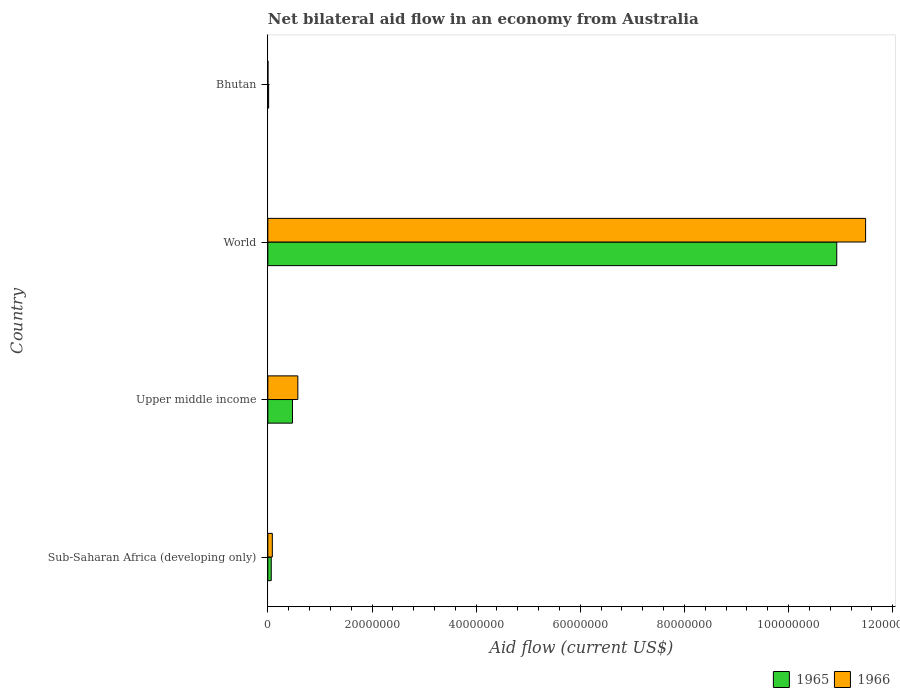How many different coloured bars are there?
Your response must be concise. 2. Are the number of bars on each tick of the Y-axis equal?
Your response must be concise. Yes. How many bars are there on the 2nd tick from the top?
Your answer should be very brief. 2. What is the label of the 1st group of bars from the top?
Your answer should be compact. Bhutan. In how many cases, is the number of bars for a given country not equal to the number of legend labels?
Your answer should be very brief. 0. What is the net bilateral aid flow in 1965 in Upper middle income?
Give a very brief answer. 4.73e+06. Across all countries, what is the maximum net bilateral aid flow in 1965?
Your answer should be compact. 1.09e+08. Across all countries, what is the minimum net bilateral aid flow in 1965?
Offer a terse response. 1.50e+05. In which country was the net bilateral aid flow in 1966 minimum?
Offer a terse response. Bhutan. What is the total net bilateral aid flow in 1965 in the graph?
Your response must be concise. 1.15e+08. What is the difference between the net bilateral aid flow in 1966 in Bhutan and that in Sub-Saharan Africa (developing only)?
Offer a very short reply. -8.40e+05. What is the difference between the net bilateral aid flow in 1965 in Sub-Saharan Africa (developing only) and the net bilateral aid flow in 1966 in World?
Make the answer very short. -1.14e+08. What is the average net bilateral aid flow in 1965 per country?
Provide a succinct answer. 2.87e+07. What is the ratio of the net bilateral aid flow in 1966 in Upper middle income to that in World?
Provide a short and direct response. 0.05. What is the difference between the highest and the second highest net bilateral aid flow in 1965?
Give a very brief answer. 1.05e+08. What is the difference between the highest and the lowest net bilateral aid flow in 1965?
Your response must be concise. 1.09e+08. Is the sum of the net bilateral aid flow in 1965 in Sub-Saharan Africa (developing only) and World greater than the maximum net bilateral aid flow in 1966 across all countries?
Offer a very short reply. No. What does the 1st bar from the top in World represents?
Your answer should be very brief. 1966. What does the 2nd bar from the bottom in World represents?
Provide a short and direct response. 1966. How many bars are there?
Keep it short and to the point. 8. How many countries are there in the graph?
Give a very brief answer. 4. Are the values on the major ticks of X-axis written in scientific E-notation?
Ensure brevity in your answer.  No. Does the graph contain grids?
Your answer should be very brief. No. Where does the legend appear in the graph?
Make the answer very short. Bottom right. How many legend labels are there?
Keep it short and to the point. 2. What is the title of the graph?
Make the answer very short. Net bilateral aid flow in an economy from Australia. Does "1966" appear as one of the legend labels in the graph?
Offer a very short reply. Yes. What is the label or title of the Y-axis?
Provide a short and direct response. Country. What is the Aid flow (current US$) of 1965 in Sub-Saharan Africa (developing only)?
Give a very brief answer. 6.50e+05. What is the Aid flow (current US$) in 1966 in Sub-Saharan Africa (developing only)?
Offer a very short reply. 8.60e+05. What is the Aid flow (current US$) in 1965 in Upper middle income?
Your answer should be very brief. 4.73e+06. What is the Aid flow (current US$) of 1966 in Upper middle income?
Ensure brevity in your answer.  5.76e+06. What is the Aid flow (current US$) in 1965 in World?
Your answer should be compact. 1.09e+08. What is the Aid flow (current US$) in 1966 in World?
Ensure brevity in your answer.  1.15e+08. What is the Aid flow (current US$) in 1966 in Bhutan?
Your answer should be very brief. 2.00e+04. Across all countries, what is the maximum Aid flow (current US$) in 1965?
Make the answer very short. 1.09e+08. Across all countries, what is the maximum Aid flow (current US$) in 1966?
Make the answer very short. 1.15e+08. Across all countries, what is the minimum Aid flow (current US$) in 1966?
Ensure brevity in your answer.  2.00e+04. What is the total Aid flow (current US$) in 1965 in the graph?
Ensure brevity in your answer.  1.15e+08. What is the total Aid flow (current US$) of 1966 in the graph?
Provide a succinct answer. 1.21e+08. What is the difference between the Aid flow (current US$) of 1965 in Sub-Saharan Africa (developing only) and that in Upper middle income?
Make the answer very short. -4.08e+06. What is the difference between the Aid flow (current US$) in 1966 in Sub-Saharan Africa (developing only) and that in Upper middle income?
Give a very brief answer. -4.90e+06. What is the difference between the Aid flow (current US$) of 1965 in Sub-Saharan Africa (developing only) and that in World?
Provide a succinct answer. -1.09e+08. What is the difference between the Aid flow (current US$) in 1966 in Sub-Saharan Africa (developing only) and that in World?
Keep it short and to the point. -1.14e+08. What is the difference between the Aid flow (current US$) of 1966 in Sub-Saharan Africa (developing only) and that in Bhutan?
Make the answer very short. 8.40e+05. What is the difference between the Aid flow (current US$) of 1965 in Upper middle income and that in World?
Keep it short and to the point. -1.05e+08. What is the difference between the Aid flow (current US$) of 1966 in Upper middle income and that in World?
Your answer should be compact. -1.09e+08. What is the difference between the Aid flow (current US$) of 1965 in Upper middle income and that in Bhutan?
Keep it short and to the point. 4.58e+06. What is the difference between the Aid flow (current US$) in 1966 in Upper middle income and that in Bhutan?
Your response must be concise. 5.74e+06. What is the difference between the Aid flow (current US$) of 1965 in World and that in Bhutan?
Make the answer very short. 1.09e+08. What is the difference between the Aid flow (current US$) in 1966 in World and that in Bhutan?
Ensure brevity in your answer.  1.15e+08. What is the difference between the Aid flow (current US$) in 1965 in Sub-Saharan Africa (developing only) and the Aid flow (current US$) in 1966 in Upper middle income?
Ensure brevity in your answer.  -5.11e+06. What is the difference between the Aid flow (current US$) of 1965 in Sub-Saharan Africa (developing only) and the Aid flow (current US$) of 1966 in World?
Ensure brevity in your answer.  -1.14e+08. What is the difference between the Aid flow (current US$) in 1965 in Sub-Saharan Africa (developing only) and the Aid flow (current US$) in 1966 in Bhutan?
Ensure brevity in your answer.  6.30e+05. What is the difference between the Aid flow (current US$) of 1965 in Upper middle income and the Aid flow (current US$) of 1966 in World?
Provide a succinct answer. -1.10e+08. What is the difference between the Aid flow (current US$) of 1965 in Upper middle income and the Aid flow (current US$) of 1966 in Bhutan?
Your response must be concise. 4.71e+06. What is the difference between the Aid flow (current US$) in 1965 in World and the Aid flow (current US$) in 1966 in Bhutan?
Make the answer very short. 1.09e+08. What is the average Aid flow (current US$) of 1965 per country?
Keep it short and to the point. 2.87e+07. What is the average Aid flow (current US$) in 1966 per country?
Make the answer very short. 3.04e+07. What is the difference between the Aid flow (current US$) in 1965 and Aid flow (current US$) in 1966 in Sub-Saharan Africa (developing only)?
Your response must be concise. -2.10e+05. What is the difference between the Aid flow (current US$) of 1965 and Aid flow (current US$) of 1966 in Upper middle income?
Give a very brief answer. -1.03e+06. What is the difference between the Aid flow (current US$) in 1965 and Aid flow (current US$) in 1966 in World?
Offer a terse response. -5.54e+06. What is the difference between the Aid flow (current US$) of 1965 and Aid flow (current US$) of 1966 in Bhutan?
Your answer should be very brief. 1.30e+05. What is the ratio of the Aid flow (current US$) in 1965 in Sub-Saharan Africa (developing only) to that in Upper middle income?
Offer a very short reply. 0.14. What is the ratio of the Aid flow (current US$) in 1966 in Sub-Saharan Africa (developing only) to that in Upper middle income?
Keep it short and to the point. 0.15. What is the ratio of the Aid flow (current US$) of 1965 in Sub-Saharan Africa (developing only) to that in World?
Ensure brevity in your answer.  0.01. What is the ratio of the Aid flow (current US$) of 1966 in Sub-Saharan Africa (developing only) to that in World?
Offer a terse response. 0.01. What is the ratio of the Aid flow (current US$) in 1965 in Sub-Saharan Africa (developing only) to that in Bhutan?
Your response must be concise. 4.33. What is the ratio of the Aid flow (current US$) in 1965 in Upper middle income to that in World?
Your answer should be compact. 0.04. What is the ratio of the Aid flow (current US$) in 1966 in Upper middle income to that in World?
Keep it short and to the point. 0.05. What is the ratio of the Aid flow (current US$) of 1965 in Upper middle income to that in Bhutan?
Give a very brief answer. 31.53. What is the ratio of the Aid flow (current US$) of 1966 in Upper middle income to that in Bhutan?
Your answer should be very brief. 288. What is the ratio of the Aid flow (current US$) in 1965 in World to that in Bhutan?
Give a very brief answer. 728.33. What is the ratio of the Aid flow (current US$) in 1966 in World to that in Bhutan?
Your answer should be very brief. 5739.5. What is the difference between the highest and the second highest Aid flow (current US$) in 1965?
Offer a terse response. 1.05e+08. What is the difference between the highest and the second highest Aid flow (current US$) in 1966?
Give a very brief answer. 1.09e+08. What is the difference between the highest and the lowest Aid flow (current US$) in 1965?
Your response must be concise. 1.09e+08. What is the difference between the highest and the lowest Aid flow (current US$) of 1966?
Your response must be concise. 1.15e+08. 